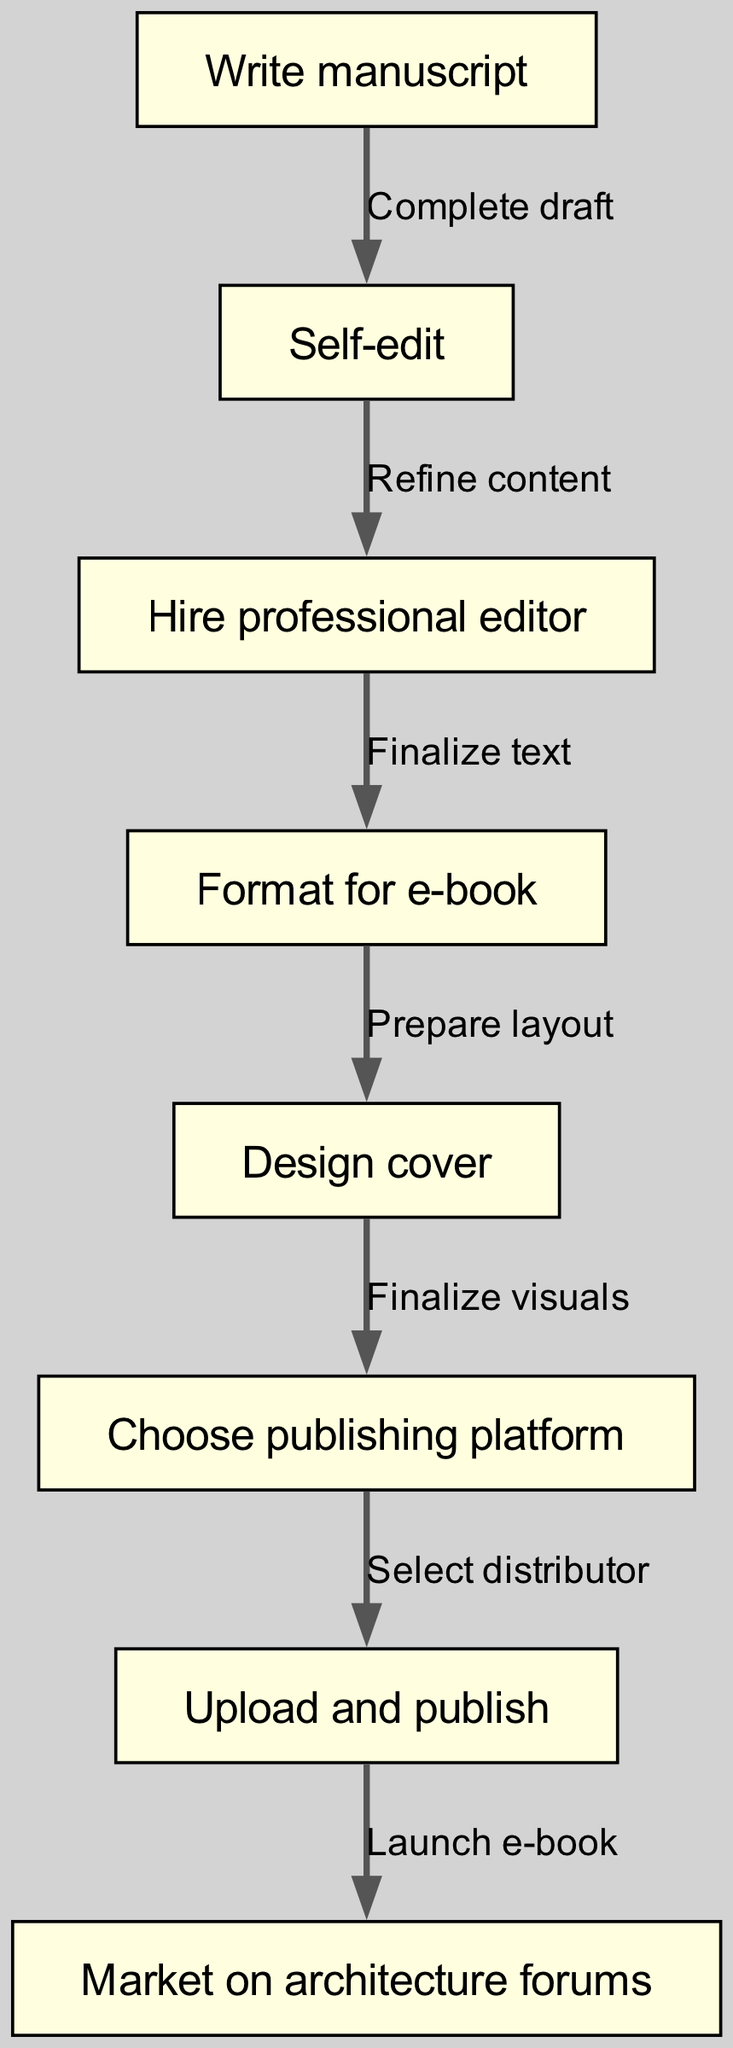What are the total nodes in the diagram? The diagram lists eight distinct steps in the e-book publishing workflow, as indicated by the eight nodes present.
Answer: 8 What is the last step in the workflow? The flowchart indicates that the last step in the e-book publishing workflow is "Market on architecture forums," which is the final node in the sequence.
Answer: Market on architecture forums What comes after "Choose publishing platform"? Following the "Choose publishing platform" node, the next step in the workflow is "Upload and publish," as represented by the direct connection between these two components.
Answer: Upload and publish Which node directly connects to "Finalize text"? According to the diagram, "Format for e-book" is the node that follows "Finalize text," establishing a direct flow between them in the e-book publishing process.
Answer: Format for e-book What is the first step in the e-book publishing workflow? The first step indicated in the flowchart is "Write manuscript," which begins the entire process for aspiring authors.
Answer: Write manuscript How many edges are present in the diagram? Analyzing the connections between the nodes, there are seven edges that denote the relationships and flow from one step to the next in the workflow.
Answer: 7 What are the two key steps between "Self-edit" and "Market on architecture forums"? The two steps that connect "Self-edit" to "Market on architecture forums" are "Hire professional editor" and "Upload and publish," which form a continuous path along the workflow.
Answer: Hire professional editor, Upload and publish What does "Design cover" lead to? The "Design cover" node directly leads to the "Choose publishing platform" step, indicating the next action after designing the book cover.
Answer: Choose publishing platform What action follows after "Launch e-book"? The action that follows "Launch e-book" is "Market on architecture forums," designating the continuation of efforts after the e-book is published.
Answer: Market on architecture forums 